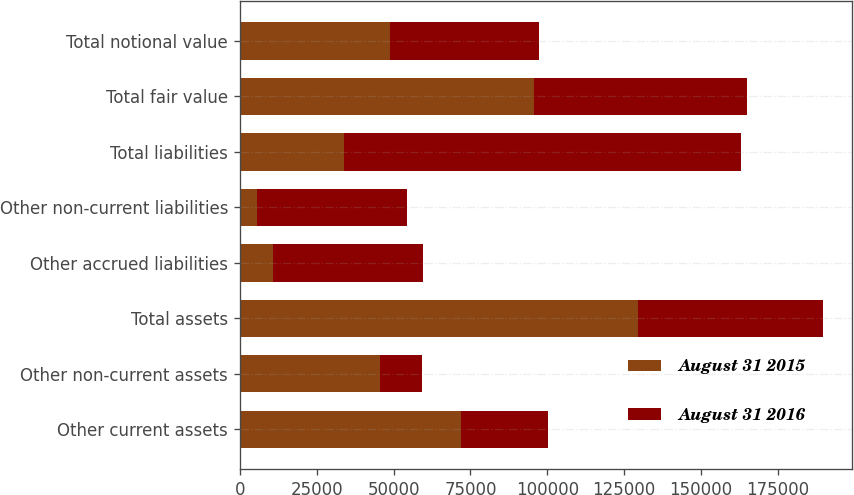<chart> <loc_0><loc_0><loc_500><loc_500><stacked_bar_chart><ecel><fcel>Other current assets<fcel>Other non-current assets<fcel>Total assets<fcel>Other accrued liabilities<fcel>Other non-current liabilities<fcel>Total liabilities<fcel>Total fair value<fcel>Total notional value<nl><fcel>August 31 2015<fcel>71955<fcel>45683<fcel>129603<fcel>10820<fcel>5547<fcel>33774<fcel>95829<fcel>48714.5<nl><fcel>August 31 2016<fcel>28282<fcel>13503<fcel>60018<fcel>48683<fcel>48746<fcel>129291<fcel>69273<fcel>48714.5<nl></chart> 